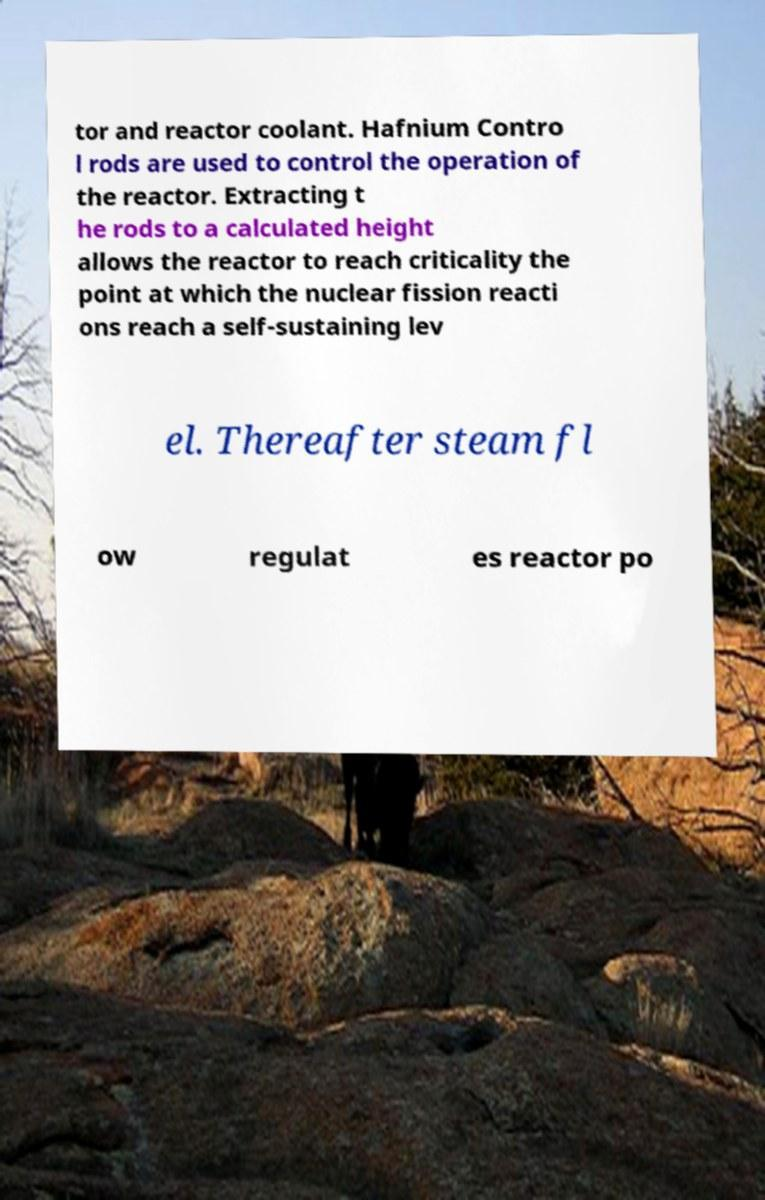Can you accurately transcribe the text from the provided image for me? tor and reactor coolant. Hafnium Contro l rods are used to control the operation of the reactor. Extracting t he rods to a calculated height allows the reactor to reach criticality the point at which the nuclear fission reacti ons reach a self-sustaining lev el. Thereafter steam fl ow regulat es reactor po 